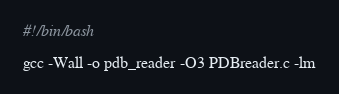Convert code to text. <code><loc_0><loc_0><loc_500><loc_500><_Bash_>#!/bin/bash

gcc -Wall -o pdb_reader -O3 PDBreader.c -lm

</code> 